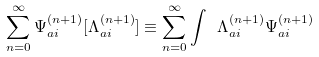Convert formula to latex. <formula><loc_0><loc_0><loc_500><loc_500>\sum _ { n = 0 } ^ { \infty } { \Psi } ^ { ( n + 1 ) } _ { a i } [ { \Lambda } _ { a i } ^ { ( n + 1 ) } ] \equiv \sum _ { n = 0 } ^ { \infty } \int \ { \Lambda } _ { a i } ^ { ( n + 1 ) } { \Psi } ^ { ( n + 1 ) } _ { a i }</formula> 